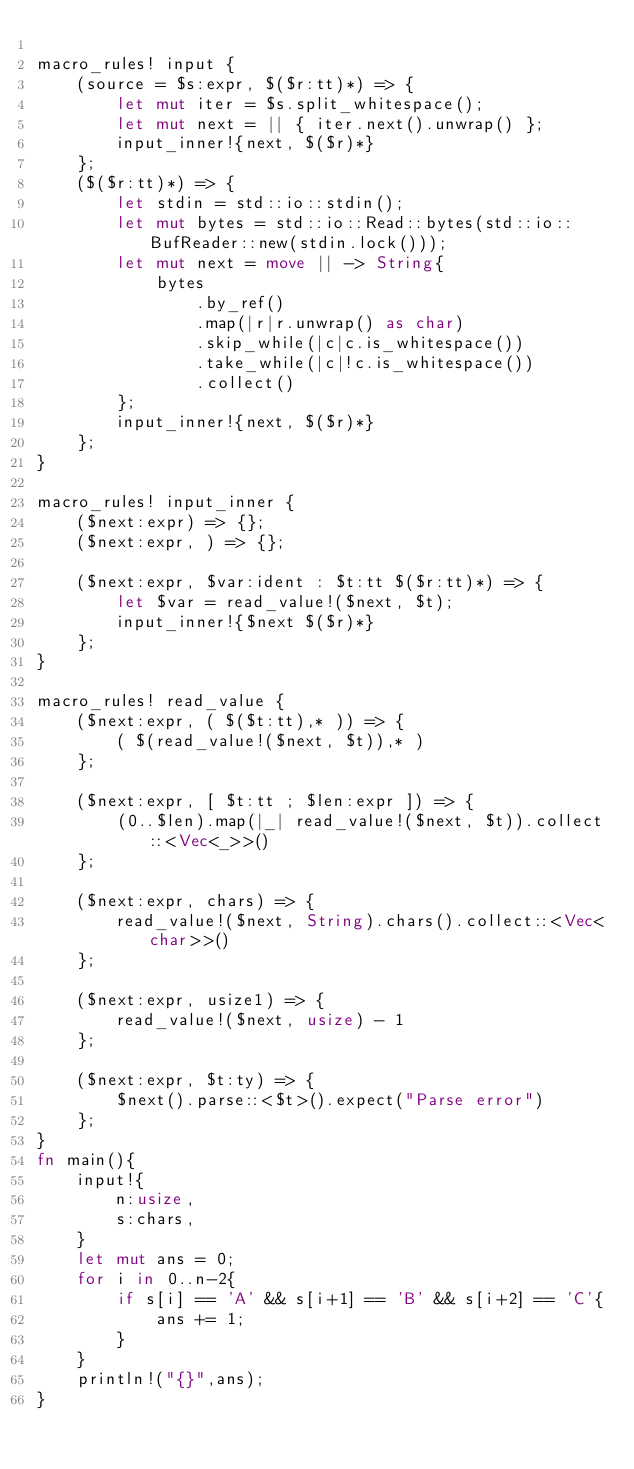Convert code to text. <code><loc_0><loc_0><loc_500><loc_500><_Rust_>
macro_rules! input {
    (source = $s:expr, $($r:tt)*) => {
        let mut iter = $s.split_whitespace();
        let mut next = || { iter.next().unwrap() };
        input_inner!{next, $($r)*}
    };
    ($($r:tt)*) => {
        let stdin = std::io::stdin();
        let mut bytes = std::io::Read::bytes(std::io::BufReader::new(stdin.lock()));
        let mut next = move || -> String{
            bytes
                .by_ref()
                .map(|r|r.unwrap() as char)
                .skip_while(|c|c.is_whitespace())
                .take_while(|c|!c.is_whitespace())
                .collect()
        };
        input_inner!{next, $($r)*}
    };
}

macro_rules! input_inner {
    ($next:expr) => {};
    ($next:expr, ) => {};

    ($next:expr, $var:ident : $t:tt $($r:tt)*) => {
        let $var = read_value!($next, $t);
        input_inner!{$next $($r)*}
    };
}

macro_rules! read_value {
    ($next:expr, ( $($t:tt),* )) => {
        ( $(read_value!($next, $t)),* )
    };

    ($next:expr, [ $t:tt ; $len:expr ]) => {
        (0..$len).map(|_| read_value!($next, $t)).collect::<Vec<_>>()
    };

    ($next:expr, chars) => {
        read_value!($next, String).chars().collect::<Vec<char>>()
    };

    ($next:expr, usize1) => {
        read_value!($next, usize) - 1
    };

    ($next:expr, $t:ty) => {
        $next().parse::<$t>().expect("Parse error")
    };
}
fn main(){
    input!{
        n:usize,
        s:chars,
    }
    let mut ans = 0;
    for i in 0..n-2{
        if s[i] == 'A' && s[i+1] == 'B' && s[i+2] == 'C'{
            ans += 1;
        }
    }
    println!("{}",ans);
}</code> 